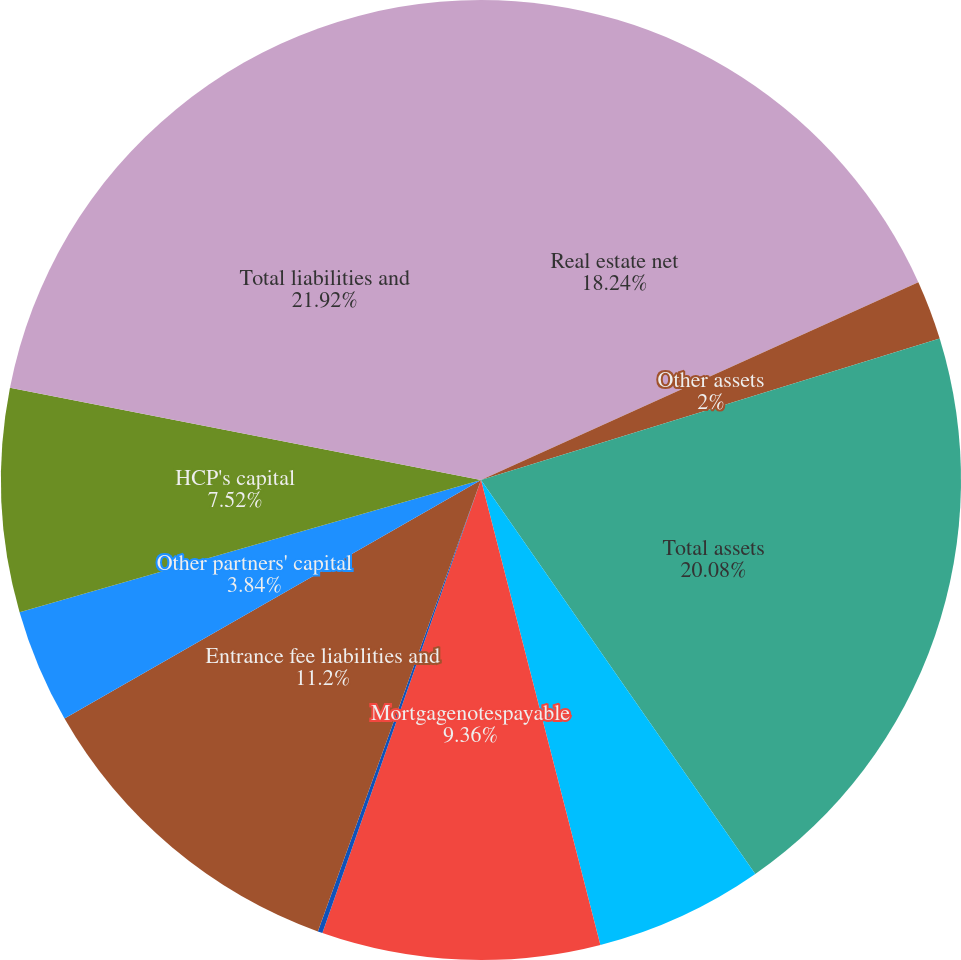<chart> <loc_0><loc_0><loc_500><loc_500><pie_chart><fcel>Real estate net<fcel>Other assets<fcel>Total assets<fcel>Notespayable<fcel>Mortgagenotespayable<fcel>Accounts payable<fcel>Entrance fee liabilities and<fcel>Other partners' capital<fcel>HCP's capital<fcel>Total liabilities and<nl><fcel>18.24%<fcel>2.0%<fcel>20.08%<fcel>5.68%<fcel>9.36%<fcel>0.16%<fcel>11.2%<fcel>3.84%<fcel>7.52%<fcel>21.92%<nl></chart> 